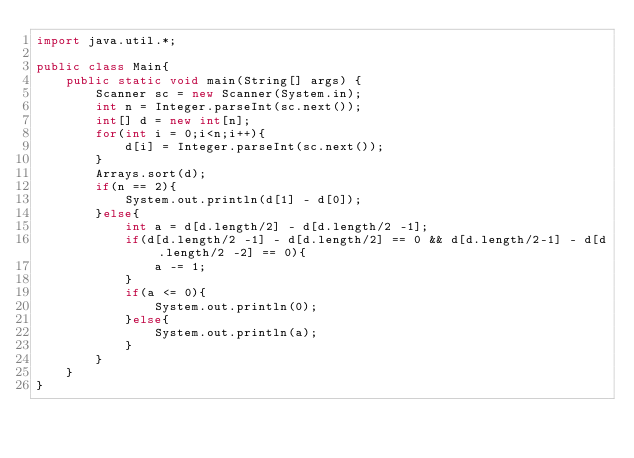<code> <loc_0><loc_0><loc_500><loc_500><_Java_>import java.util.*;

public class Main{
    public static void main(String[] args) {
        Scanner sc = new Scanner(System.in);
        int n = Integer.parseInt(sc.next());
        int[] d = new int[n];
        for(int i = 0;i<n;i++){
            d[i] = Integer.parseInt(sc.next());
        }
        Arrays.sort(d);
        if(n == 2){
            System.out.println(d[1] - d[0]);
        }else{
            int a = d[d.length/2] - d[d.length/2 -1];
            if(d[d.length/2 -1] - d[d.length/2] == 0 && d[d.length/2-1] - d[d.length/2 -2] == 0){
                a -= 1;
            }
            if(a <= 0){
                System.out.println(0);
            }else{
                System.out.println(a);
            }
        }
    }
}</code> 